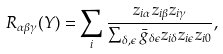<formula> <loc_0><loc_0><loc_500><loc_500>R _ { \alpha \beta \gamma } ( Y ) = \sum _ { i } \frac { z _ { i \alpha } z _ { i \beta } z _ { i \gamma } } { \sum _ { \delta , \epsilon } \bar { g } _ { \delta \epsilon } z _ { i \delta } z _ { i \epsilon } z _ { i 0 } } ,</formula> 